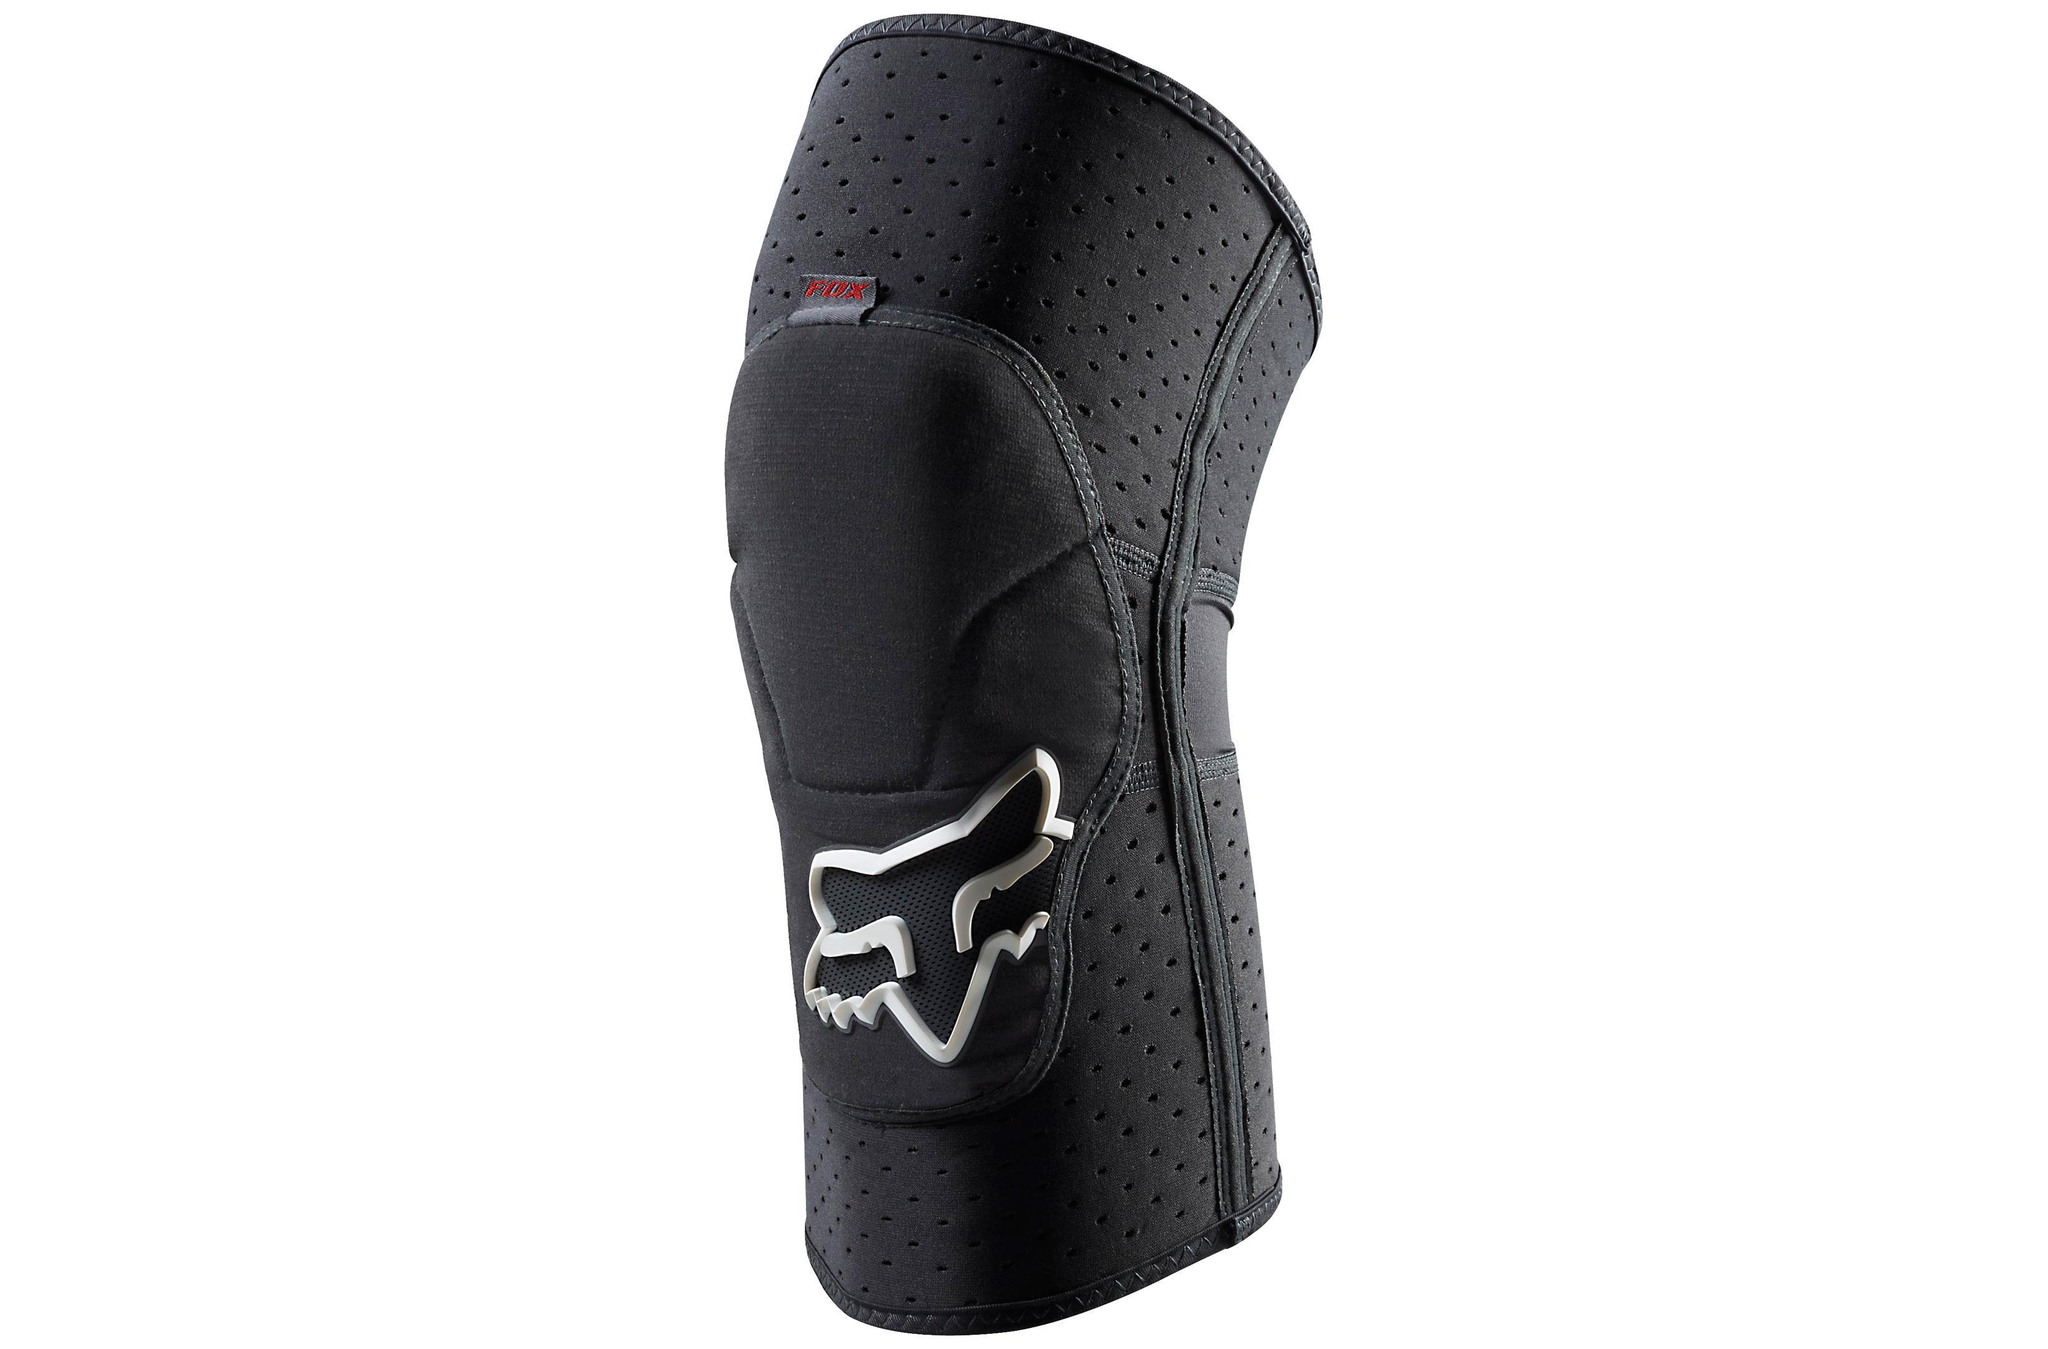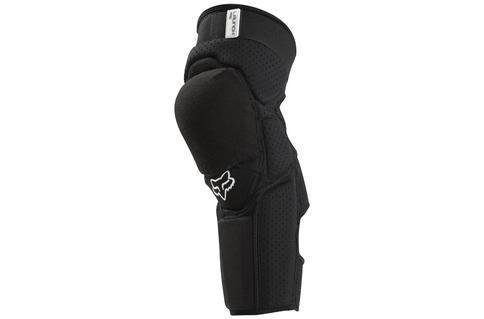The first image is the image on the left, the second image is the image on the right. Given the left and right images, does the statement "both knee pads are black and shown unworn" hold true? Answer yes or no. Yes. 